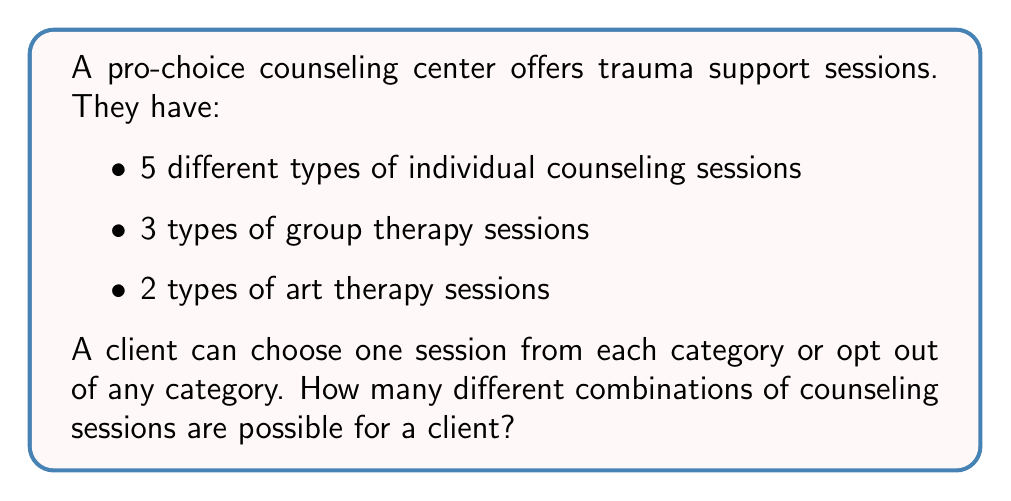What is the answer to this math problem? Let's approach this step-by-step using the multiplication principle of combinatorics:

1) For individual counseling:
   - The client has 5 choices plus the option to not choose (opt out)
   - Total options = 5 + 1 = 6

2) For group therapy:
   - The client has 3 choices plus the option to not choose
   - Total options = 3 + 1 = 4

3) For art therapy:
   - The client has 2 choices plus the option to not choose
   - Total options = 2 + 1 = 3

Now, we apply the multiplication principle. The total number of combinations is the product of the number of choices for each category:

$$ \text{Total combinations} = 6 \times 4 \times 3 = 72 $$

This can be represented mathematically as:

$$ \text{Total combinations} = (n_1 + 1)(n_2 + 1)(n_3 + 1) $$

Where $n_1$, $n_2$, and $n_3$ are the number of choices in each category, and we add 1 to each to account for the option to opt out.

In this case:
$$ (5 + 1)(3 + 1)(2 + 1) = 6 \times 4 \times 3 = 72 $$
Answer: 72 combinations 